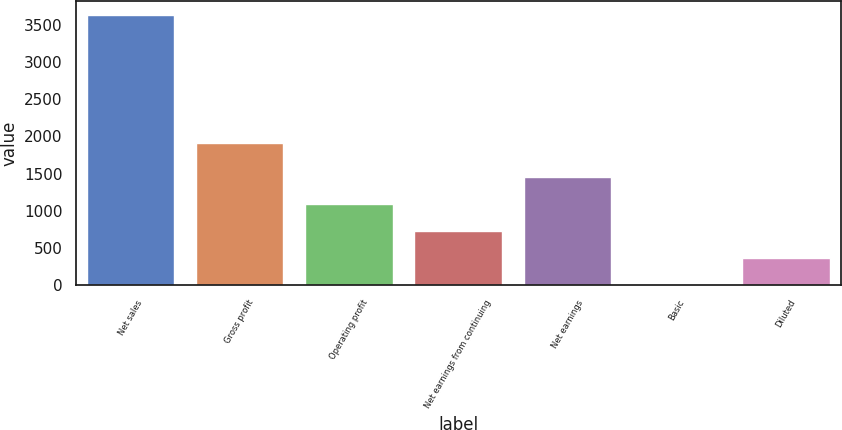<chart> <loc_0><loc_0><loc_500><loc_500><bar_chart><fcel>Net sales<fcel>Gross profit<fcel>Operating profit<fcel>Net earnings from continuing<fcel>Net earnings<fcel>Basic<fcel>Diluted<nl><fcel>3635.9<fcel>1917.6<fcel>1091.22<fcel>727.7<fcel>1454.74<fcel>0.66<fcel>364.18<nl></chart> 